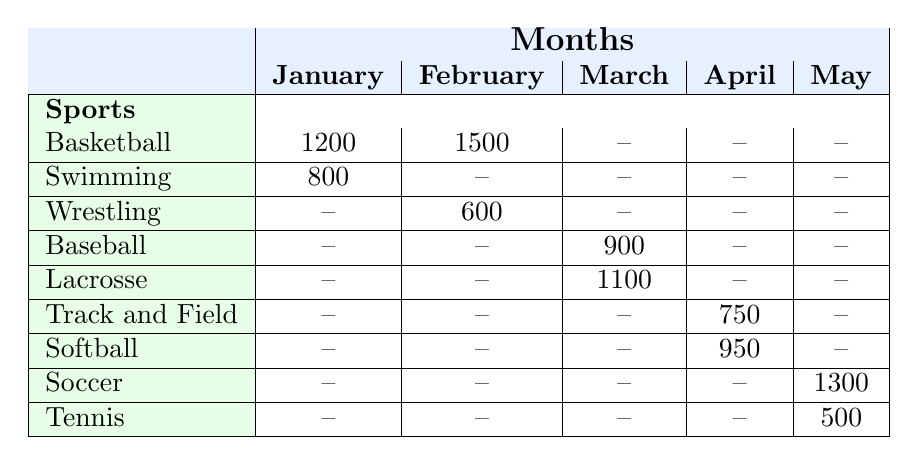What was the attendance for basketball in February? The table shows that the attendance for basketball in February is listed directly under the February column and the Basketball row, which shows an attendance of 1500.
Answer: 1500 Which sport had the lowest attendance in April? In April, the table lists Track and Field with an attendance of 750 and Softball with an attendance of 950. The lower value is for Track and Field, making it the sport with the lowest attendance that month.
Answer: Track and Field What is the total attendance for sports in March? The attendance for sports in March consists of Baseball with 900 and Lacrosse with 1100. Adding these values gives: 900 + 1100 = 2000. Therefore, the total attendance for March is 2000.
Answer: 2000 Did attendance for soccer exceed 1200 in May? The table reports that attendance for soccer in May is 1300, which is greater than 1200. Therefore, the statement is true.
Answer: Yes How does the attendance for tennis compare to that of swimming? The attendance for swimming is 800, and for tennis, it is 500. Comparing these values shows that swimming has higher attendance.
Answer: Swimming has higher attendance 